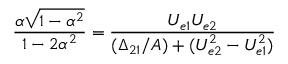<formula> <loc_0><loc_0><loc_500><loc_500>\frac { \alpha \sqrt { 1 - \alpha ^ { 2 } } } { 1 - 2 \alpha ^ { 2 } } = \frac { U _ { e 1 } U _ { e 2 } } { ( \Delta _ { 2 1 } / A ) + ( U _ { e 2 } ^ { 2 } - U _ { e 1 } ^ { 2 } ) }</formula> 